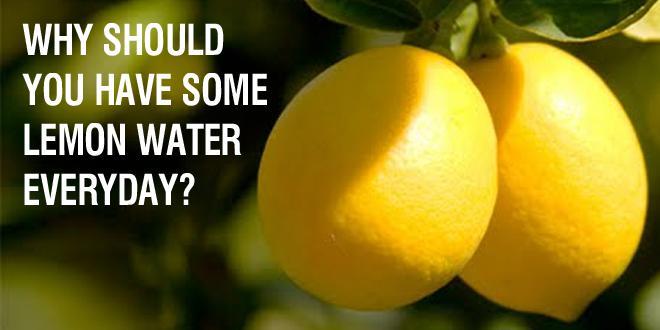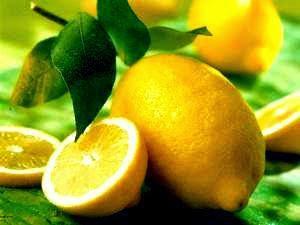The first image is the image on the left, the second image is the image on the right. Considering the images on both sides, is "The combined images include cut and whole lemons and a clear glass containing citrus juice." valid? Answer yes or no. No. The first image is the image on the left, the second image is the image on the right. Evaluate the accuracy of this statement regarding the images: "There are only whole lemons in one of the images.". Is it true? Answer yes or no. Yes. 